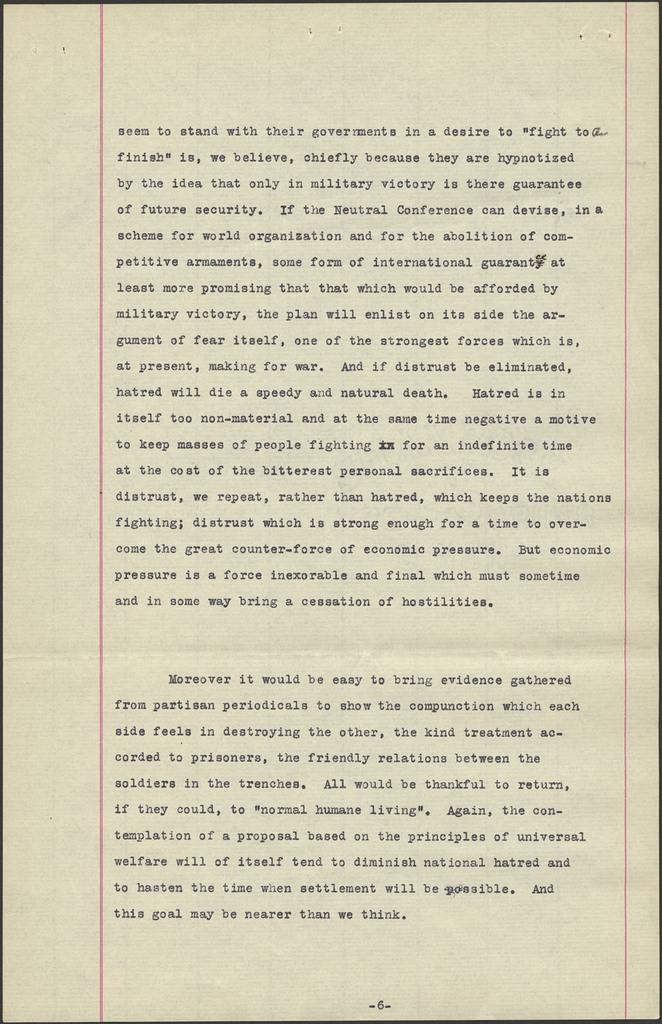<image>
Offer a succinct explanation of the picture presented. A sheet of paper with text printed on it and is numbered page 6. 